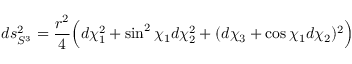<formula> <loc_0><loc_0><loc_500><loc_500>d s _ { S ^ { 3 } } ^ { 2 } = \frac { r ^ { 2 } } { 4 } \left ( d \chi _ { 1 } ^ { 2 } + \sin ^ { 2 } { \chi _ { 1 } } d \chi _ { 2 } ^ { 2 } + ( d \chi _ { 3 } + \cos { \chi _ { 1 } } d \chi _ { 2 } ) ^ { 2 } \right )</formula> 